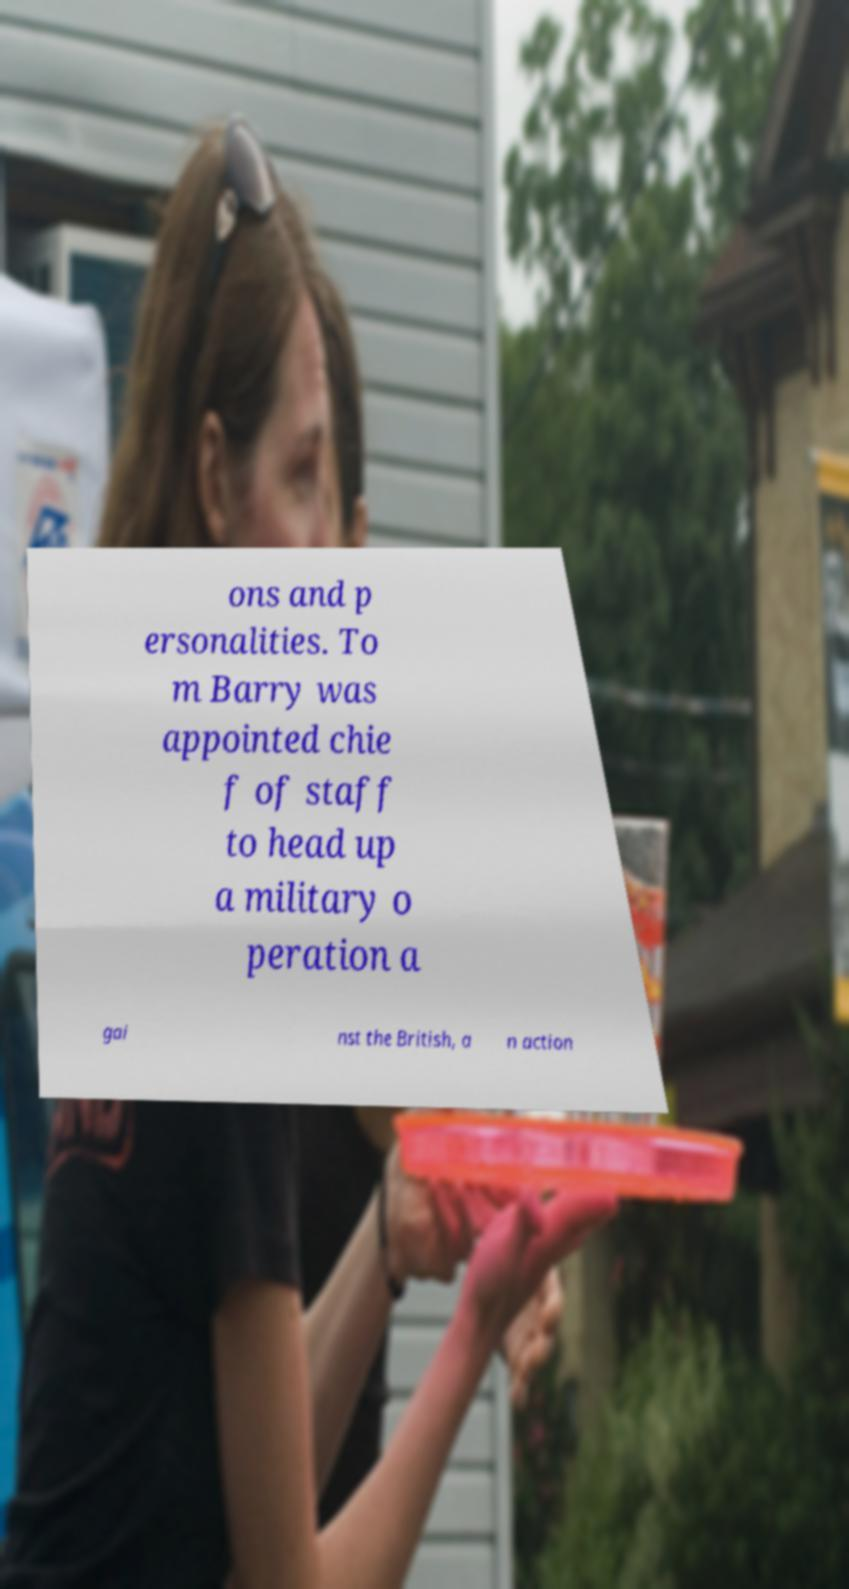Can you read and provide the text displayed in the image?This photo seems to have some interesting text. Can you extract and type it out for me? ons and p ersonalities. To m Barry was appointed chie f of staff to head up a military o peration a gai nst the British, a n action 